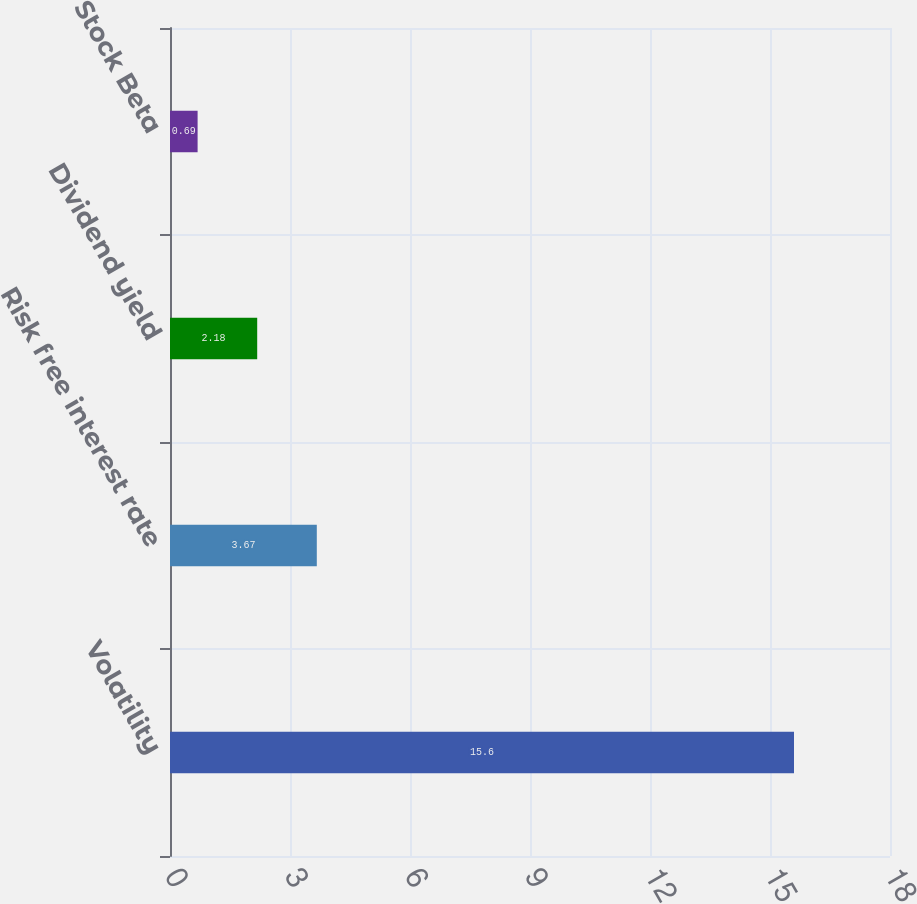Convert chart to OTSL. <chart><loc_0><loc_0><loc_500><loc_500><bar_chart><fcel>Volatility<fcel>Risk free interest rate<fcel>Dividend yield<fcel>Stock Beta<nl><fcel>15.6<fcel>3.67<fcel>2.18<fcel>0.69<nl></chart> 